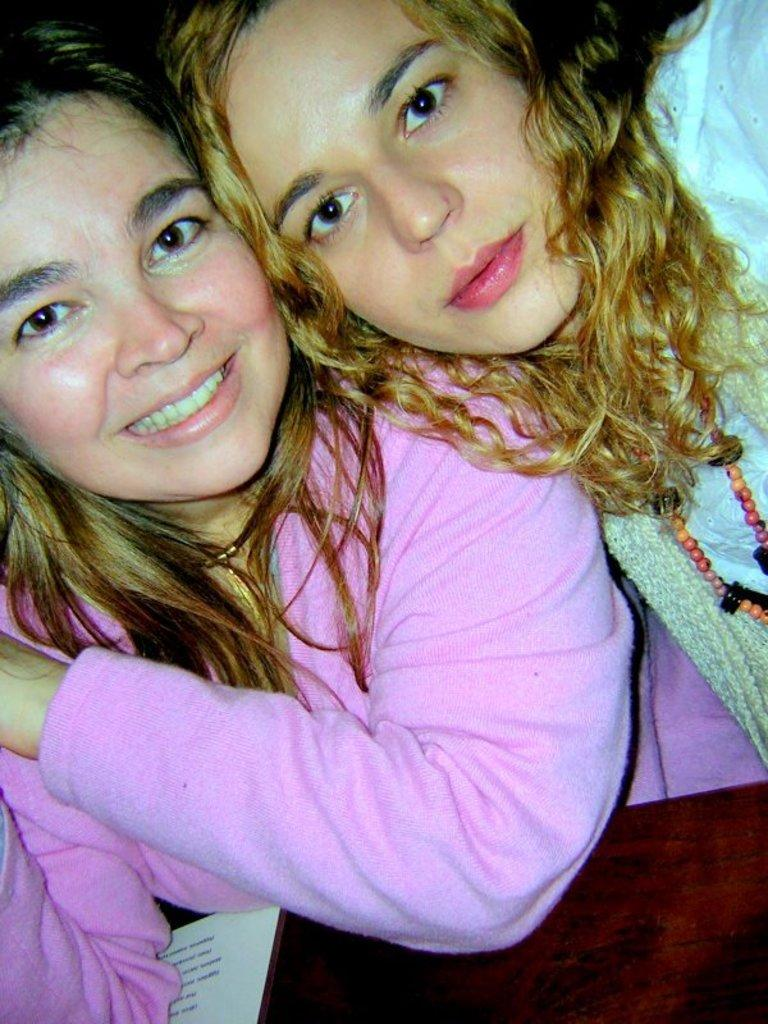How many people are in the image? There are two ladies in the image. What is present in the image besides the ladies? There is a table in the image. What is placed on the table? A paper is placed on the table. What type of instrument is being played by the ladies in the image? There is no instrument present in the image; the ladies are not playing any instrument. 